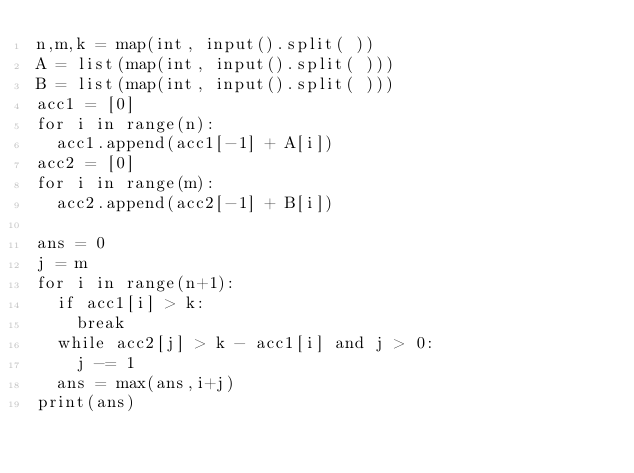Convert code to text. <code><loc_0><loc_0><loc_500><loc_500><_Python_>n,m,k = map(int, input().split( ))
A = list(map(int, input().split( )))
B = list(map(int, input().split( )))
acc1 = [0]
for i in range(n):
  acc1.append(acc1[-1] + A[i])
acc2 = [0]
for i in range(m):
  acc2.append(acc2[-1] + B[i])

ans = 0
j = m
for i in range(n+1):
  if acc1[i] > k:
    break
  while acc2[j] > k - acc1[i] and j > 0:
    j -= 1
  ans = max(ans,i+j)
print(ans)
  </code> 